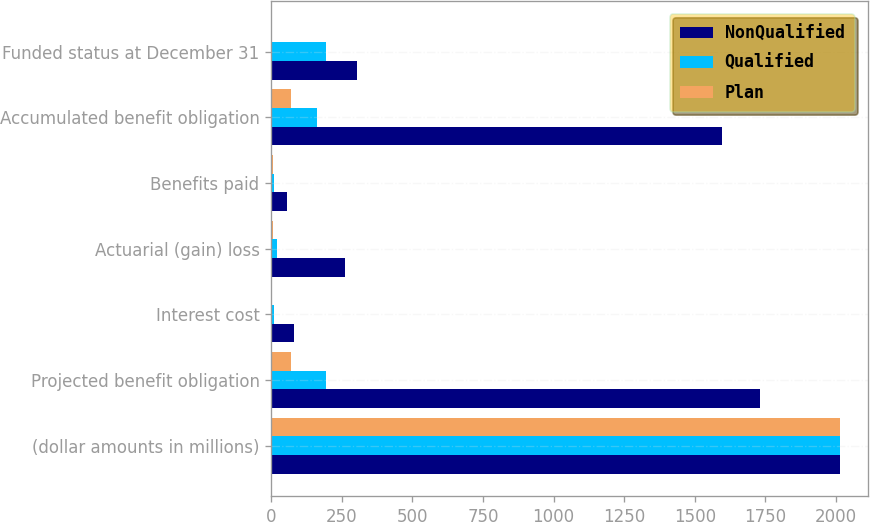<chart> <loc_0><loc_0><loc_500><loc_500><stacked_bar_chart><ecel><fcel>(dollar amounts in millions)<fcel>Projected benefit obligation<fcel>Interest cost<fcel>Actuarial (gain) loss<fcel>Benefits paid<fcel>Accumulated benefit obligation<fcel>Funded status at December 31<nl><fcel>NonQualified<fcel>2013<fcel>1731<fcel>80<fcel>260<fcel>56<fcel>1598<fcel>304<nl><fcel>Qualified<fcel>2013<fcel>195<fcel>9<fcel>21<fcel>9<fcel>163<fcel>195<nl><fcel>Plan<fcel>2013<fcel>69<fcel>3<fcel>7<fcel>6<fcel>69<fcel>2<nl></chart> 